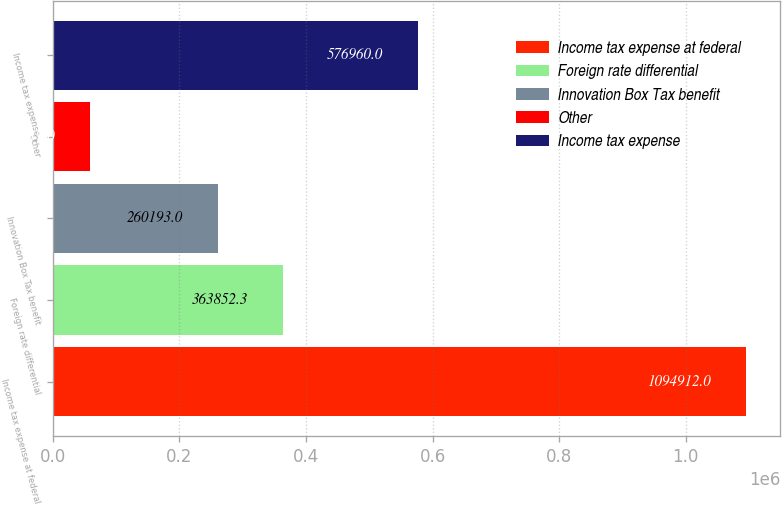<chart> <loc_0><loc_0><loc_500><loc_500><bar_chart><fcel>Income tax expense at federal<fcel>Foreign rate differential<fcel>Innovation Box Tax benefit<fcel>Other<fcel>Income tax expense<nl><fcel>1.09491e+06<fcel>363852<fcel>260193<fcel>58319<fcel>576960<nl></chart> 